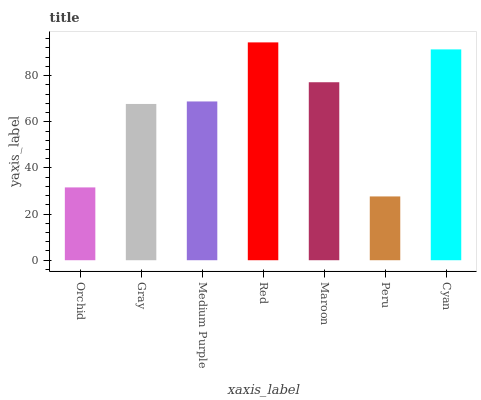Is Peru the minimum?
Answer yes or no. Yes. Is Red the maximum?
Answer yes or no. Yes. Is Gray the minimum?
Answer yes or no. No. Is Gray the maximum?
Answer yes or no. No. Is Gray greater than Orchid?
Answer yes or no. Yes. Is Orchid less than Gray?
Answer yes or no. Yes. Is Orchid greater than Gray?
Answer yes or no. No. Is Gray less than Orchid?
Answer yes or no. No. Is Medium Purple the high median?
Answer yes or no. Yes. Is Medium Purple the low median?
Answer yes or no. Yes. Is Cyan the high median?
Answer yes or no. No. Is Red the low median?
Answer yes or no. No. 